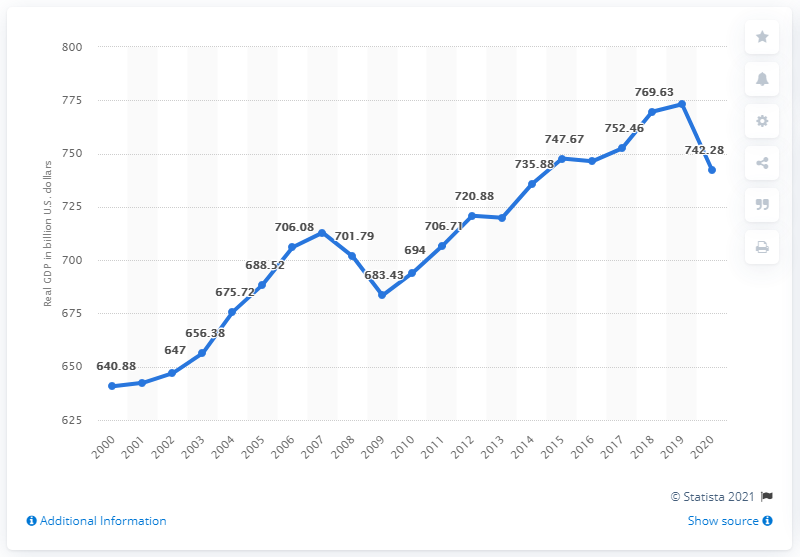Give some essential details in this illustration. The real GDP of Illinois in 2020 was 742.28. In 2018, the real Gross Domestic Product (GDP) of Illinois was 773.14 billion dollars. 